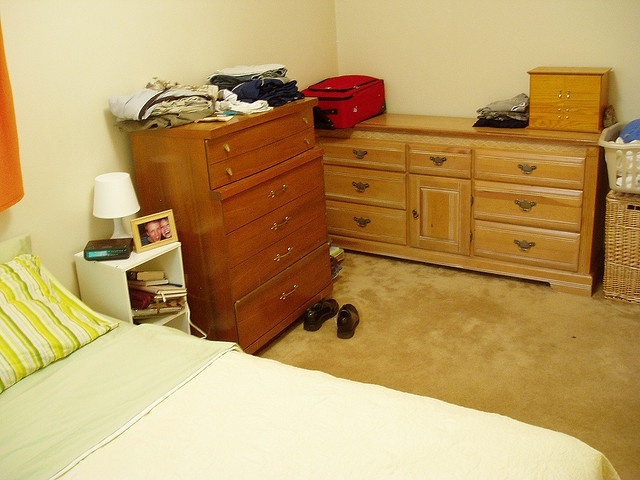Describe the objects in this image and their specific colors. I can see bed in khaki, beige, and gold tones, suitcase in khaki, maroon, black, and brown tones, clock in khaki, maroon, olive, black, and darkgreen tones, book in khaki, tan, and maroon tones, and book in khaki, olive, black, and tan tones in this image. 